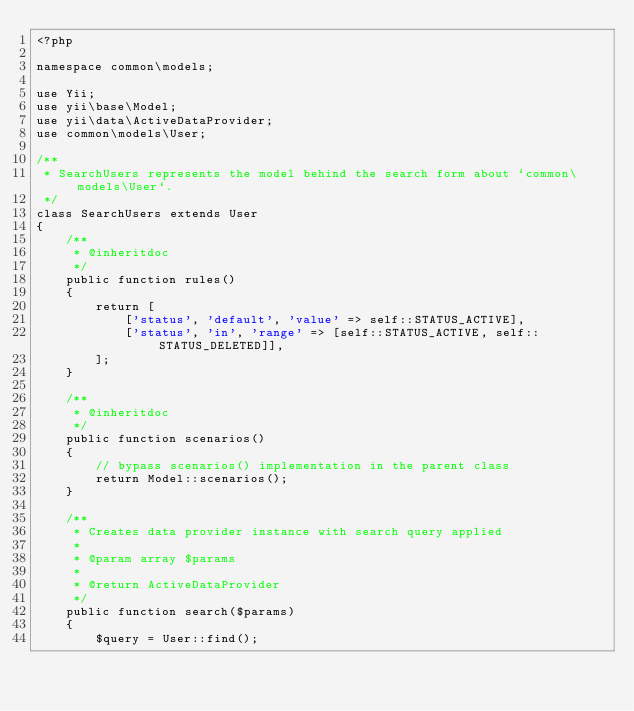<code> <loc_0><loc_0><loc_500><loc_500><_PHP_><?php

namespace common\models;

use Yii;
use yii\base\Model;
use yii\data\ActiveDataProvider;
use common\models\User;

/**
 * SearchUsers represents the model behind the search form about `common\models\User`.
 */
class SearchUsers extends User
{
    /**
     * @inheritdoc
     */
    public function rules()
    {
        return [
            ['status', 'default', 'value' => self::STATUS_ACTIVE],
            ['status', 'in', 'range' => [self::STATUS_ACTIVE, self::STATUS_DELETED]],
        ];
    }

    /**
     * @inheritdoc
     */
    public function scenarios()
    {
        // bypass scenarios() implementation in the parent class
        return Model::scenarios();
    }

    /**
     * Creates data provider instance with search query applied
     *
     * @param array $params
     *
     * @return ActiveDataProvider
     */
    public function search($params)
    {
        $query = User::find();
</code> 